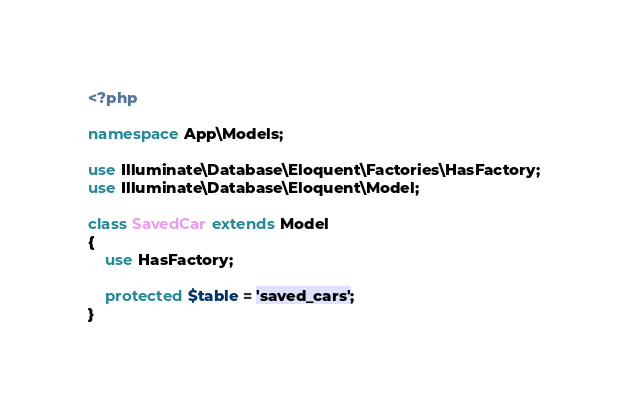Convert code to text. <code><loc_0><loc_0><loc_500><loc_500><_PHP_><?php

namespace App\Models;

use Illuminate\Database\Eloquent\Factories\HasFactory;
use Illuminate\Database\Eloquent\Model;

class SavedCar extends Model
{
    use HasFactory;

    protected $table = 'saved_cars';
}
</code> 